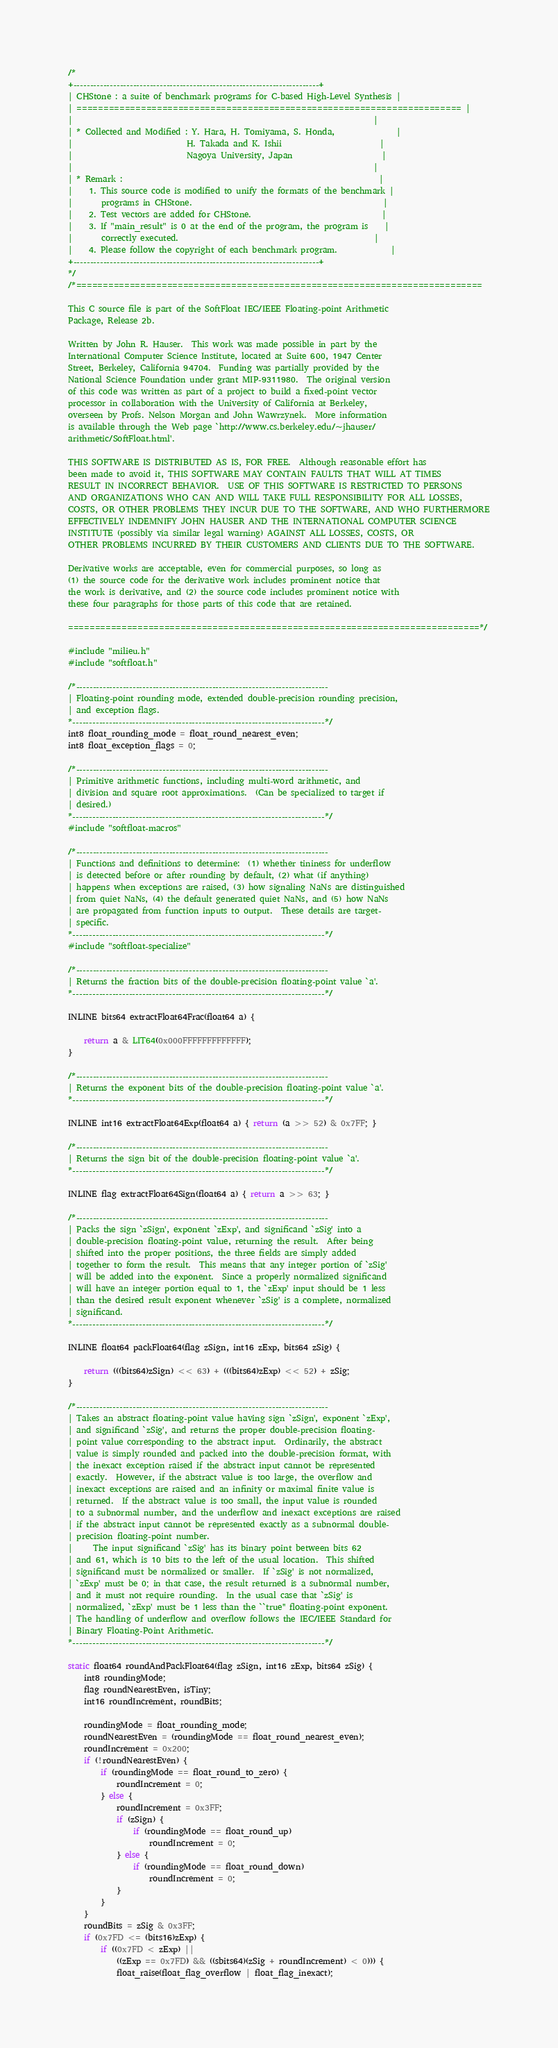Convert code to text. <code><loc_0><loc_0><loc_500><loc_500><_C_>/*
+--------------------------------------------------------------------------+
| CHStone : a suite of benchmark programs for C-based High-Level Synthesis |
| ======================================================================== |
|                                                                          |
| * Collected and Modified : Y. Hara, H. Tomiyama, S. Honda,               |
|                            H. Takada and K. Ishii                        |
|                            Nagoya University, Japan                      |
|                                                                          |
| * Remark :                                                               |
|    1. This source code is modified to unify the formats of the benchmark |
|       programs in CHStone.                                               |
|    2. Test vectors are added for CHStone.                                |
|    3. If "main_result" is 0 at the end of the program, the program is    |
|       correctly executed.                                                |
|    4. Please follow the copyright of each benchmark program.             |
+--------------------------------------------------------------------------+
*/
/*============================================================================

This C source file is part of the SoftFloat IEC/IEEE Floating-point Arithmetic
Package, Release 2b.

Written by John R. Hauser.  This work was made possible in part by the
International Computer Science Institute, located at Suite 600, 1947 Center
Street, Berkeley, California 94704.  Funding was partially provided by the
National Science Foundation under grant MIP-9311980.  The original version
of this code was written as part of a project to build a fixed-point vector
processor in collaboration with the University of California at Berkeley,
overseen by Profs. Nelson Morgan and John Wawrzynek.  More information
is available through the Web page `http://www.cs.berkeley.edu/~jhauser/
arithmetic/SoftFloat.html'.

THIS SOFTWARE IS DISTRIBUTED AS IS, FOR FREE.  Although reasonable effort has
been made to avoid it, THIS SOFTWARE MAY CONTAIN FAULTS THAT WILL AT TIMES
RESULT IN INCORRECT BEHAVIOR.  USE OF THIS SOFTWARE IS RESTRICTED TO PERSONS
AND ORGANIZATIONS WHO CAN AND WILL TAKE FULL RESPONSIBILITY FOR ALL LOSSES,
COSTS, OR OTHER PROBLEMS THEY INCUR DUE TO THE SOFTWARE, AND WHO FURTHERMORE
EFFECTIVELY INDEMNIFY JOHN HAUSER AND THE INTERNATIONAL COMPUTER SCIENCE
INSTITUTE (possibly via similar legal warning) AGAINST ALL LOSSES, COSTS, OR
OTHER PROBLEMS INCURRED BY THEIR CUSTOMERS AND CLIENTS DUE TO THE SOFTWARE.

Derivative works are acceptable, even for commercial purposes, so long as
(1) the source code for the derivative work includes prominent notice that
the work is derivative, and (2) the source code includes prominent notice with
these four paragraphs for those parts of this code that are retained.

=============================================================================*/

#include "milieu.h"
#include "softfloat.h"

/*----------------------------------------------------------------------------
| Floating-point rounding mode, extended double-precision rounding precision,
| and exception flags.
*----------------------------------------------------------------------------*/
int8 float_rounding_mode = float_round_nearest_even;
int8 float_exception_flags = 0;

/*----------------------------------------------------------------------------
| Primitive arithmetic functions, including multi-word arithmetic, and
| division and square root approximations.  (Can be specialized to target if
| desired.)
*----------------------------------------------------------------------------*/
#include "softfloat-macros"

/*----------------------------------------------------------------------------
| Functions and definitions to determine:  (1) whether tininess for underflow
| is detected before or after rounding by default, (2) what (if anything)
| happens when exceptions are raised, (3) how signaling NaNs are distinguished
| from quiet NaNs, (4) the default generated quiet NaNs, and (5) how NaNs
| are propagated from function inputs to output.  These details are target-
| specific.
*----------------------------------------------------------------------------*/
#include "softfloat-specialize"

/*----------------------------------------------------------------------------
| Returns the fraction bits of the double-precision floating-point value `a'.
*----------------------------------------------------------------------------*/

INLINE bits64 extractFloat64Frac(float64 a) {

    return a & LIT64(0x000FFFFFFFFFFFFF);
}

/*----------------------------------------------------------------------------
| Returns the exponent bits of the double-precision floating-point value `a'.
*----------------------------------------------------------------------------*/

INLINE int16 extractFloat64Exp(float64 a) { return (a >> 52) & 0x7FF; }

/*----------------------------------------------------------------------------
| Returns the sign bit of the double-precision floating-point value `a'.
*----------------------------------------------------------------------------*/

INLINE flag extractFloat64Sign(float64 a) { return a >> 63; }

/*----------------------------------------------------------------------------
| Packs the sign `zSign', exponent `zExp', and significand `zSig' into a
| double-precision floating-point value, returning the result.  After being
| shifted into the proper positions, the three fields are simply added
| together to form the result.  This means that any integer portion of `zSig'
| will be added into the exponent.  Since a properly normalized significand
| will have an integer portion equal to 1, the `zExp' input should be 1 less
| than the desired result exponent whenever `zSig' is a complete, normalized
| significand.
*----------------------------------------------------------------------------*/

INLINE float64 packFloat64(flag zSign, int16 zExp, bits64 zSig) {

    return (((bits64)zSign) << 63) + (((bits64)zExp) << 52) + zSig;
}

/*----------------------------------------------------------------------------
| Takes an abstract floating-point value having sign `zSign', exponent `zExp',
| and significand `zSig', and returns the proper double-precision floating-
| point value corresponding to the abstract input.  Ordinarily, the abstract
| value is simply rounded and packed into the double-precision format, with
| the inexact exception raised if the abstract input cannot be represented
| exactly.  However, if the abstract value is too large, the overflow and
| inexact exceptions are raised and an infinity or maximal finite value is
| returned.  If the abstract value is too small, the input value is rounded
| to a subnormal number, and the underflow and inexact exceptions are raised
| if the abstract input cannot be represented exactly as a subnormal double-
| precision floating-point number.
|     The input significand `zSig' has its binary point between bits 62
| and 61, which is 10 bits to the left of the usual location.  This shifted
| significand must be normalized or smaller.  If `zSig' is not normalized,
| `zExp' must be 0; in that case, the result returned is a subnormal number,
| and it must not require rounding.  In the usual case that `zSig' is
| normalized, `zExp' must be 1 less than the ``true'' floating-point exponent.
| The handling of underflow and overflow follows the IEC/IEEE Standard for
| Binary Floating-Point Arithmetic.
*----------------------------------------------------------------------------*/

static float64 roundAndPackFloat64(flag zSign, int16 zExp, bits64 zSig) {
    int8 roundingMode;
    flag roundNearestEven, isTiny;
    int16 roundIncrement, roundBits;

    roundingMode = float_rounding_mode;
    roundNearestEven = (roundingMode == float_round_nearest_even);
    roundIncrement = 0x200;
    if (!roundNearestEven) {
        if (roundingMode == float_round_to_zero) {
            roundIncrement = 0;
        } else {
            roundIncrement = 0x3FF;
            if (zSign) {
                if (roundingMode == float_round_up)
                    roundIncrement = 0;
            } else {
                if (roundingMode == float_round_down)
                    roundIncrement = 0;
            }
        }
    }
    roundBits = zSig & 0x3FF;
    if (0x7FD <= (bits16)zExp) {
        if ((0x7FD < zExp) ||
            ((zExp == 0x7FD) && ((sbits64)(zSig + roundIncrement) < 0))) {
            float_raise(float_flag_overflow | float_flag_inexact);</code> 